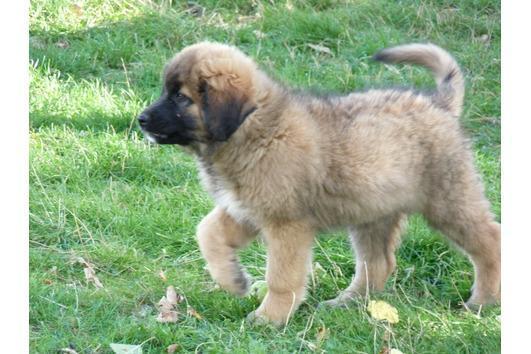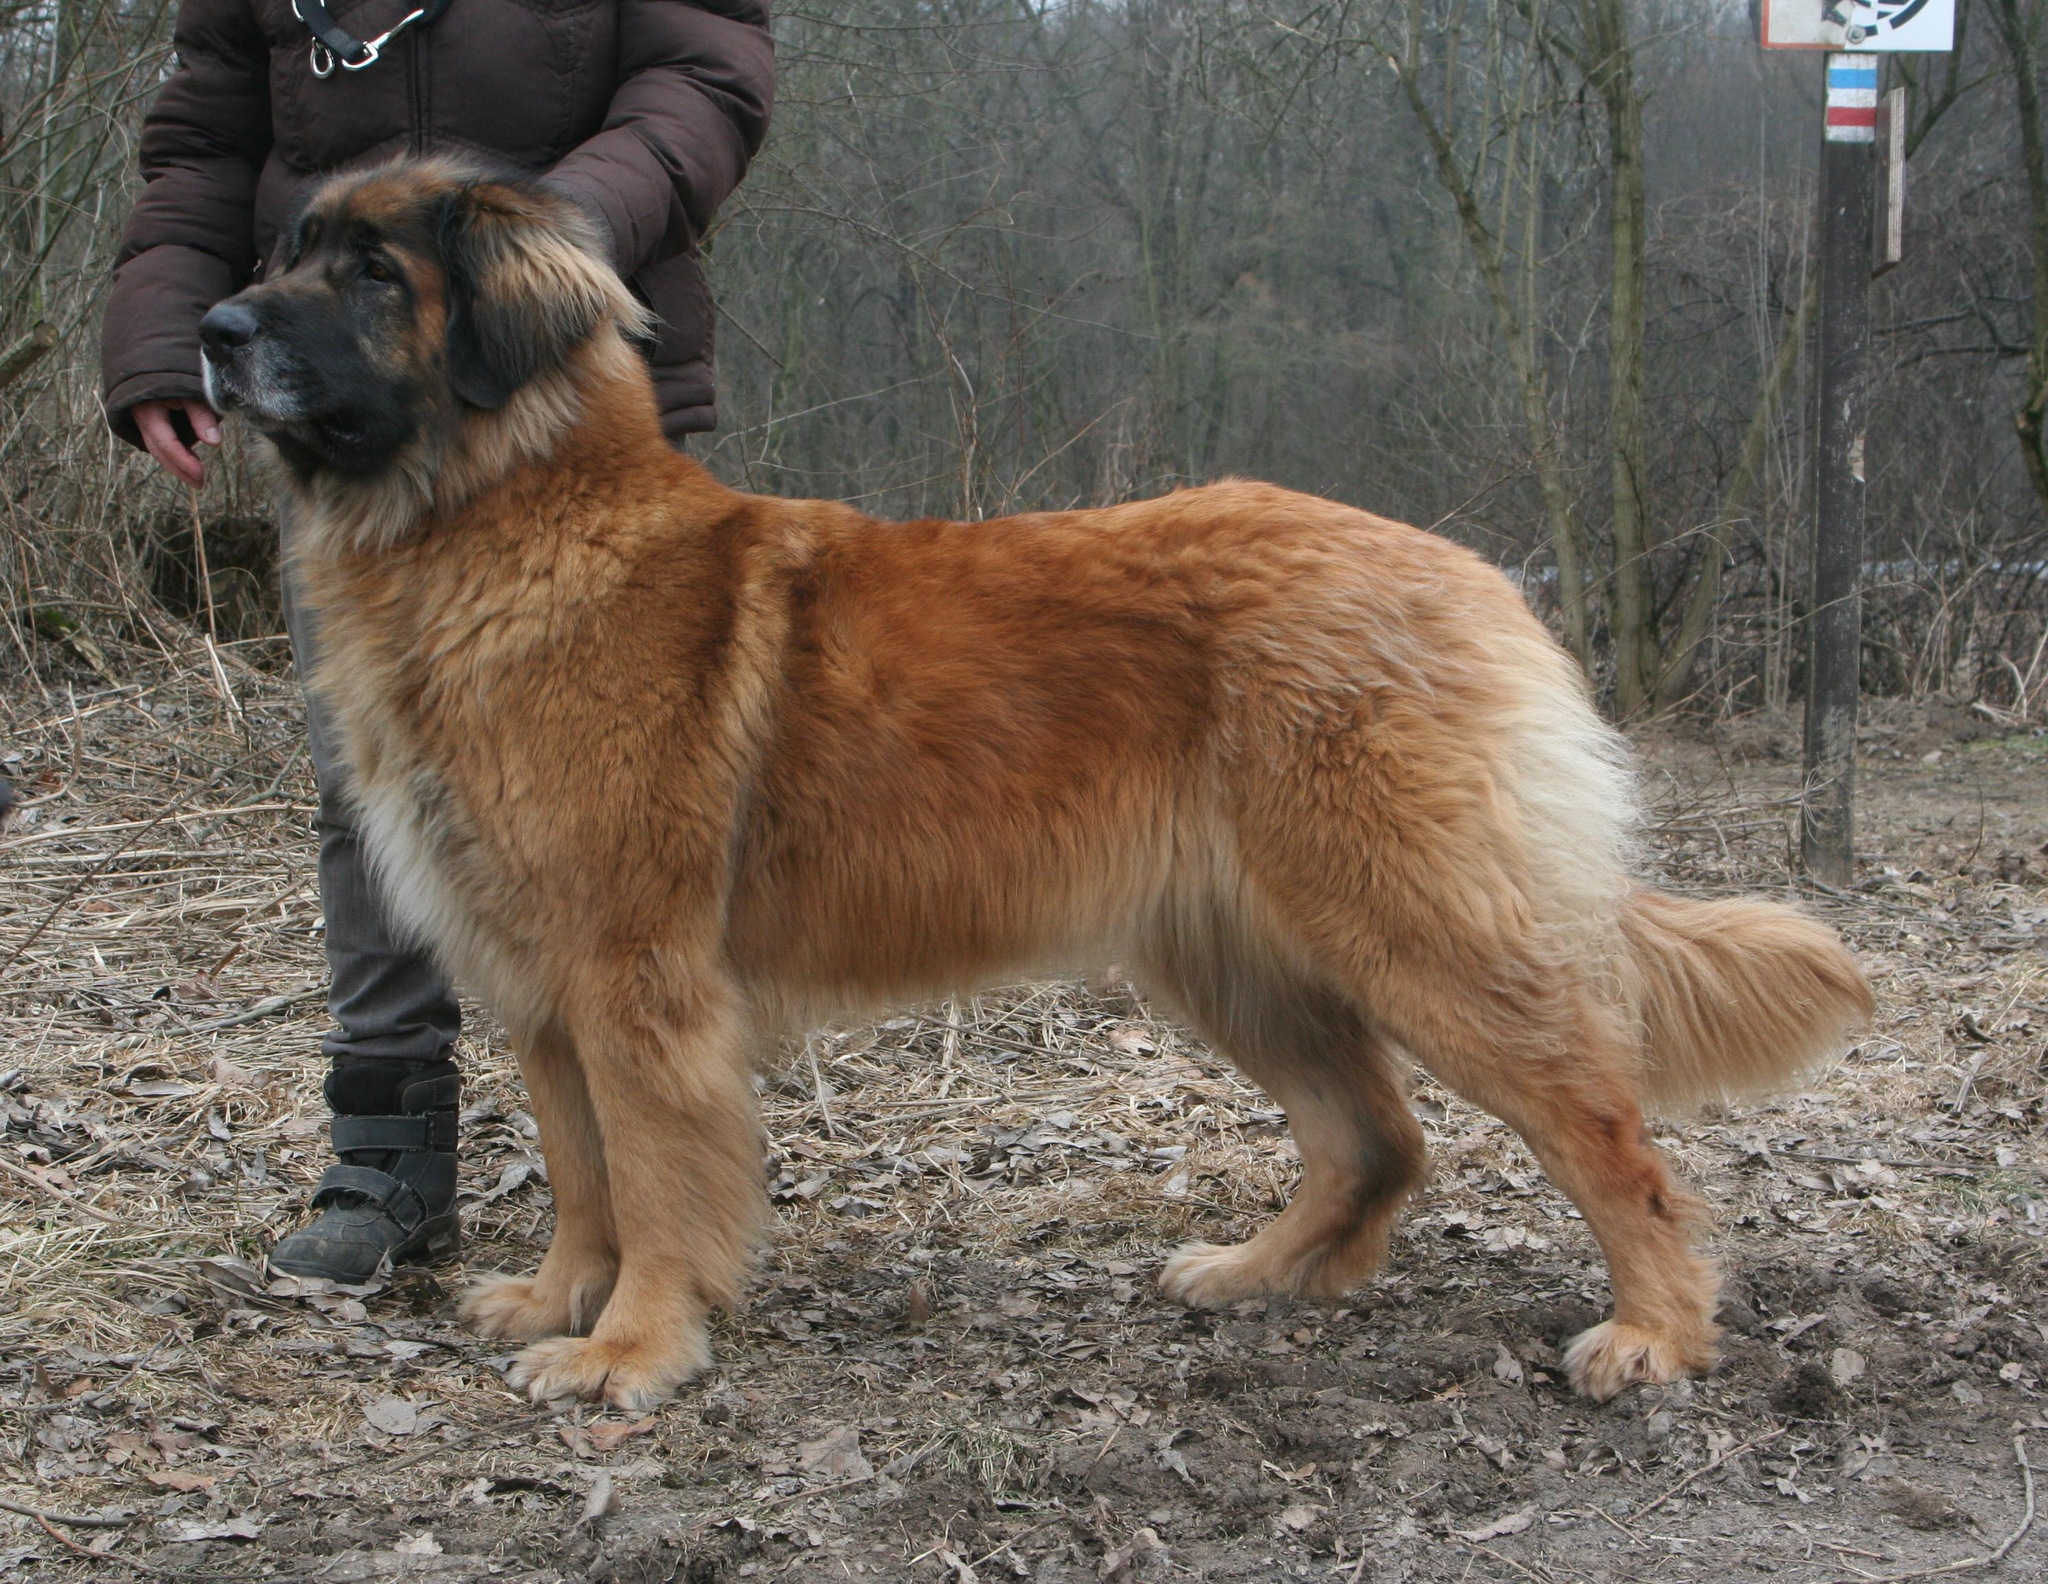The first image is the image on the left, the second image is the image on the right. For the images shown, is this caption "An image shows one person to the left of a large dog." true? Answer yes or no. Yes. The first image is the image on the left, the second image is the image on the right. Given the left and right images, does the statement "A dog is standing on the grass." hold true? Answer yes or no. Yes. 